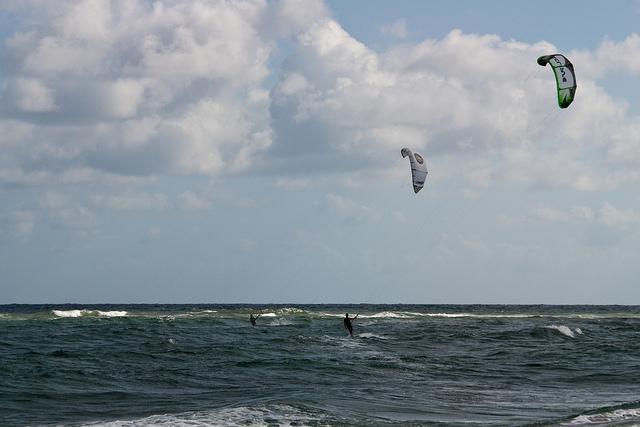How many sails are in the sky?
Give a very brief answer. 2. 